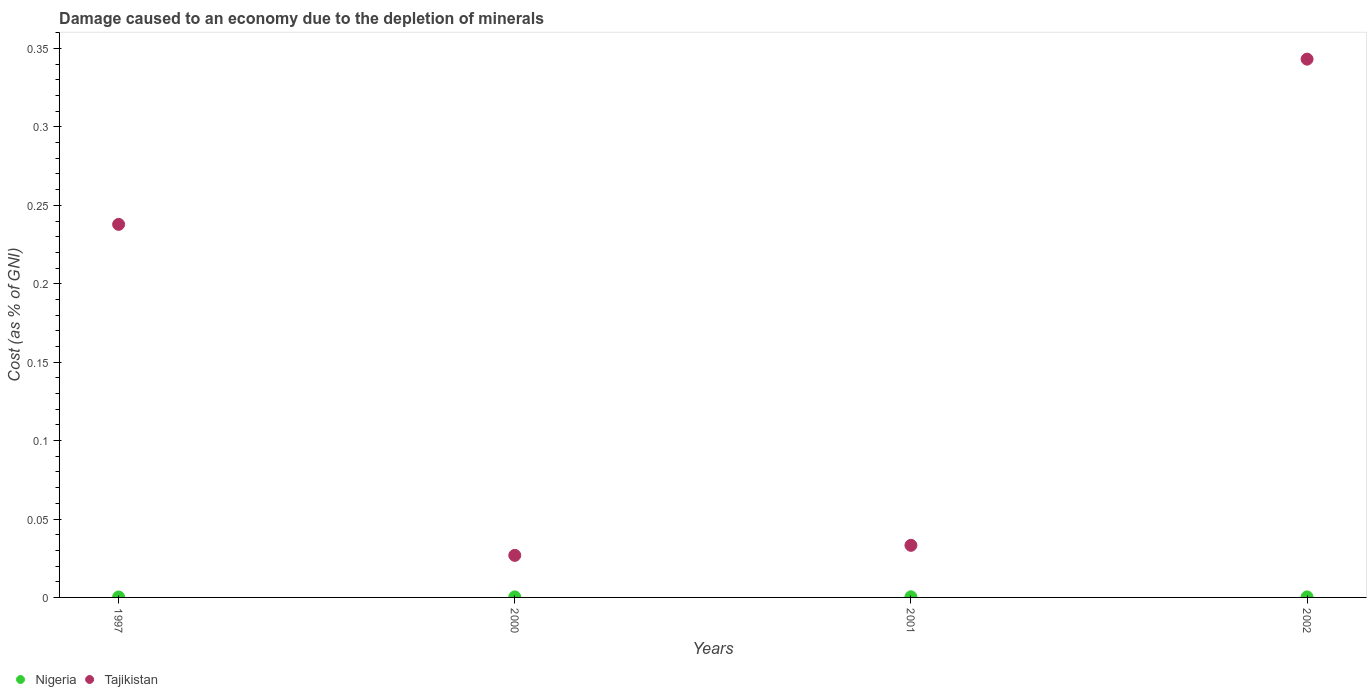How many different coloured dotlines are there?
Offer a terse response. 2. What is the cost of damage caused due to the depletion of minerals in Tajikistan in 2001?
Offer a very short reply. 0.03. Across all years, what is the maximum cost of damage caused due to the depletion of minerals in Nigeria?
Make the answer very short. 0. Across all years, what is the minimum cost of damage caused due to the depletion of minerals in Nigeria?
Your answer should be very brief. 0. In which year was the cost of damage caused due to the depletion of minerals in Tajikistan maximum?
Provide a short and direct response. 2002. In which year was the cost of damage caused due to the depletion of minerals in Tajikistan minimum?
Provide a short and direct response. 2000. What is the total cost of damage caused due to the depletion of minerals in Nigeria in the graph?
Ensure brevity in your answer.  0. What is the difference between the cost of damage caused due to the depletion of minerals in Nigeria in 1997 and that in 2002?
Provide a succinct answer. -5.686012218244601e-5. What is the difference between the cost of damage caused due to the depletion of minerals in Tajikistan in 2002 and the cost of damage caused due to the depletion of minerals in Nigeria in 1997?
Keep it short and to the point. 0.34. What is the average cost of damage caused due to the depletion of minerals in Tajikistan per year?
Provide a succinct answer. 0.16. In the year 2000, what is the difference between the cost of damage caused due to the depletion of minerals in Nigeria and cost of damage caused due to the depletion of minerals in Tajikistan?
Give a very brief answer. -0.03. What is the ratio of the cost of damage caused due to the depletion of minerals in Nigeria in 2001 to that in 2002?
Keep it short and to the point. 1.17. Is the cost of damage caused due to the depletion of minerals in Tajikistan in 1997 less than that in 2000?
Offer a very short reply. No. What is the difference between the highest and the second highest cost of damage caused due to the depletion of minerals in Tajikistan?
Your answer should be compact. 0.11. What is the difference between the highest and the lowest cost of damage caused due to the depletion of minerals in Tajikistan?
Your answer should be very brief. 0.32. Does the cost of damage caused due to the depletion of minerals in Nigeria monotonically increase over the years?
Make the answer very short. No. How many dotlines are there?
Your answer should be compact. 2. Does the graph contain any zero values?
Your answer should be very brief. No. How many legend labels are there?
Provide a succinct answer. 2. How are the legend labels stacked?
Your answer should be compact. Horizontal. What is the title of the graph?
Ensure brevity in your answer.  Damage caused to an economy due to the depletion of minerals. Does "Latin America(developing only)" appear as one of the legend labels in the graph?
Your response must be concise. No. What is the label or title of the Y-axis?
Your answer should be compact. Cost (as % of GNI). What is the Cost (as % of GNI) of Nigeria in 1997?
Offer a terse response. 0. What is the Cost (as % of GNI) of Tajikistan in 1997?
Give a very brief answer. 0.24. What is the Cost (as % of GNI) of Nigeria in 2000?
Give a very brief answer. 0. What is the Cost (as % of GNI) in Tajikistan in 2000?
Provide a short and direct response. 0.03. What is the Cost (as % of GNI) of Nigeria in 2001?
Ensure brevity in your answer.  0. What is the Cost (as % of GNI) in Tajikistan in 2001?
Your answer should be very brief. 0.03. What is the Cost (as % of GNI) of Nigeria in 2002?
Your answer should be compact. 0. What is the Cost (as % of GNI) in Tajikistan in 2002?
Provide a succinct answer. 0.34. Across all years, what is the maximum Cost (as % of GNI) of Nigeria?
Ensure brevity in your answer.  0. Across all years, what is the maximum Cost (as % of GNI) in Tajikistan?
Provide a short and direct response. 0.34. Across all years, what is the minimum Cost (as % of GNI) of Nigeria?
Make the answer very short. 0. Across all years, what is the minimum Cost (as % of GNI) of Tajikistan?
Give a very brief answer. 0.03. What is the total Cost (as % of GNI) in Nigeria in the graph?
Provide a short and direct response. 0. What is the total Cost (as % of GNI) in Tajikistan in the graph?
Offer a terse response. 0.64. What is the difference between the Cost (as % of GNI) of Nigeria in 1997 and that in 2000?
Your answer should be very brief. -0. What is the difference between the Cost (as % of GNI) in Tajikistan in 1997 and that in 2000?
Give a very brief answer. 0.21. What is the difference between the Cost (as % of GNI) of Nigeria in 1997 and that in 2001?
Keep it short and to the point. -0. What is the difference between the Cost (as % of GNI) in Tajikistan in 1997 and that in 2001?
Keep it short and to the point. 0.2. What is the difference between the Cost (as % of GNI) in Nigeria in 1997 and that in 2002?
Give a very brief answer. -0. What is the difference between the Cost (as % of GNI) in Tajikistan in 1997 and that in 2002?
Make the answer very short. -0.11. What is the difference between the Cost (as % of GNI) of Nigeria in 2000 and that in 2001?
Give a very brief answer. -0. What is the difference between the Cost (as % of GNI) of Tajikistan in 2000 and that in 2001?
Make the answer very short. -0.01. What is the difference between the Cost (as % of GNI) of Tajikistan in 2000 and that in 2002?
Make the answer very short. -0.32. What is the difference between the Cost (as % of GNI) in Nigeria in 2001 and that in 2002?
Provide a short and direct response. 0. What is the difference between the Cost (as % of GNI) in Tajikistan in 2001 and that in 2002?
Ensure brevity in your answer.  -0.31. What is the difference between the Cost (as % of GNI) in Nigeria in 1997 and the Cost (as % of GNI) in Tajikistan in 2000?
Give a very brief answer. -0.03. What is the difference between the Cost (as % of GNI) in Nigeria in 1997 and the Cost (as % of GNI) in Tajikistan in 2001?
Make the answer very short. -0.03. What is the difference between the Cost (as % of GNI) of Nigeria in 1997 and the Cost (as % of GNI) of Tajikistan in 2002?
Make the answer very short. -0.34. What is the difference between the Cost (as % of GNI) of Nigeria in 2000 and the Cost (as % of GNI) of Tajikistan in 2001?
Provide a short and direct response. -0.03. What is the difference between the Cost (as % of GNI) in Nigeria in 2000 and the Cost (as % of GNI) in Tajikistan in 2002?
Provide a succinct answer. -0.34. What is the difference between the Cost (as % of GNI) in Nigeria in 2001 and the Cost (as % of GNI) in Tajikistan in 2002?
Offer a terse response. -0.34. What is the average Cost (as % of GNI) of Nigeria per year?
Offer a terse response. 0. What is the average Cost (as % of GNI) of Tajikistan per year?
Keep it short and to the point. 0.16. In the year 1997, what is the difference between the Cost (as % of GNI) of Nigeria and Cost (as % of GNI) of Tajikistan?
Offer a terse response. -0.24. In the year 2000, what is the difference between the Cost (as % of GNI) in Nigeria and Cost (as % of GNI) in Tajikistan?
Keep it short and to the point. -0.03. In the year 2001, what is the difference between the Cost (as % of GNI) of Nigeria and Cost (as % of GNI) of Tajikistan?
Make the answer very short. -0.03. In the year 2002, what is the difference between the Cost (as % of GNI) in Nigeria and Cost (as % of GNI) in Tajikistan?
Provide a short and direct response. -0.34. What is the ratio of the Cost (as % of GNI) of Nigeria in 1997 to that in 2000?
Give a very brief answer. 0.82. What is the ratio of the Cost (as % of GNI) in Tajikistan in 1997 to that in 2000?
Make the answer very short. 8.87. What is the ratio of the Cost (as % of GNI) in Nigeria in 1997 to that in 2001?
Your answer should be compact. 0.71. What is the ratio of the Cost (as % of GNI) of Tajikistan in 1997 to that in 2001?
Give a very brief answer. 7.16. What is the ratio of the Cost (as % of GNI) of Nigeria in 1997 to that in 2002?
Keep it short and to the point. 0.83. What is the ratio of the Cost (as % of GNI) of Tajikistan in 1997 to that in 2002?
Your answer should be compact. 0.69. What is the ratio of the Cost (as % of GNI) of Nigeria in 2000 to that in 2001?
Offer a very short reply. 0.86. What is the ratio of the Cost (as % of GNI) in Tajikistan in 2000 to that in 2001?
Keep it short and to the point. 0.81. What is the ratio of the Cost (as % of GNI) in Nigeria in 2000 to that in 2002?
Ensure brevity in your answer.  1.01. What is the ratio of the Cost (as % of GNI) of Tajikistan in 2000 to that in 2002?
Offer a very short reply. 0.08. What is the ratio of the Cost (as % of GNI) in Nigeria in 2001 to that in 2002?
Provide a succinct answer. 1.17. What is the ratio of the Cost (as % of GNI) of Tajikistan in 2001 to that in 2002?
Make the answer very short. 0.1. What is the difference between the highest and the second highest Cost (as % of GNI) in Tajikistan?
Your answer should be compact. 0.11. What is the difference between the highest and the lowest Cost (as % of GNI) in Tajikistan?
Provide a short and direct response. 0.32. 